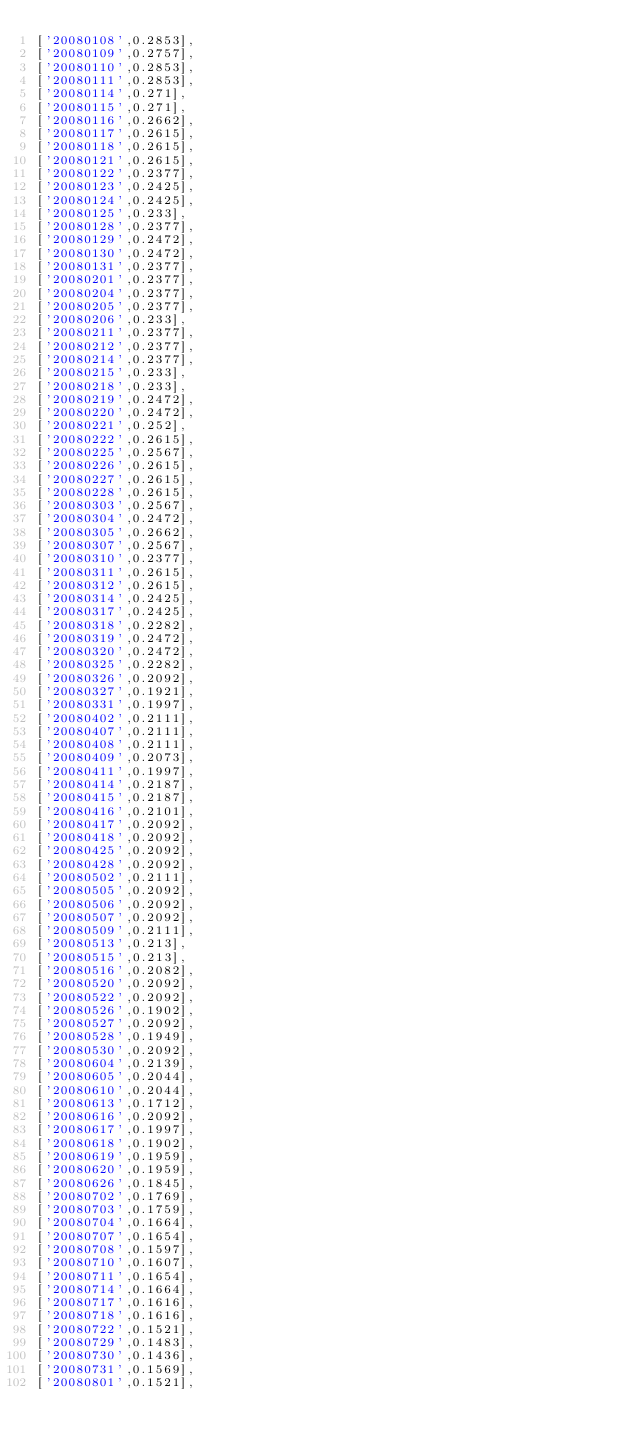Convert code to text. <code><loc_0><loc_0><loc_500><loc_500><_JavaScript_>['20080108',0.2853],
['20080109',0.2757],
['20080110',0.2853],
['20080111',0.2853],
['20080114',0.271],
['20080115',0.271],
['20080116',0.2662],
['20080117',0.2615],
['20080118',0.2615],
['20080121',0.2615],
['20080122',0.2377],
['20080123',0.2425],
['20080124',0.2425],
['20080125',0.233],
['20080128',0.2377],
['20080129',0.2472],
['20080130',0.2472],
['20080131',0.2377],
['20080201',0.2377],
['20080204',0.2377],
['20080205',0.2377],
['20080206',0.233],
['20080211',0.2377],
['20080212',0.2377],
['20080214',0.2377],
['20080215',0.233],
['20080218',0.233],
['20080219',0.2472],
['20080220',0.2472],
['20080221',0.252],
['20080222',0.2615],
['20080225',0.2567],
['20080226',0.2615],
['20080227',0.2615],
['20080228',0.2615],
['20080303',0.2567],
['20080304',0.2472],
['20080305',0.2662],
['20080307',0.2567],
['20080310',0.2377],
['20080311',0.2615],
['20080312',0.2615],
['20080314',0.2425],
['20080317',0.2425],
['20080318',0.2282],
['20080319',0.2472],
['20080320',0.2472],
['20080325',0.2282],
['20080326',0.2092],
['20080327',0.1921],
['20080331',0.1997],
['20080402',0.2111],
['20080407',0.2111],
['20080408',0.2111],
['20080409',0.2073],
['20080411',0.1997],
['20080414',0.2187],
['20080415',0.2187],
['20080416',0.2101],
['20080417',0.2092],
['20080418',0.2092],
['20080425',0.2092],
['20080428',0.2092],
['20080502',0.2111],
['20080505',0.2092],
['20080506',0.2092],
['20080507',0.2092],
['20080509',0.2111],
['20080513',0.213],
['20080515',0.213],
['20080516',0.2082],
['20080520',0.2092],
['20080522',0.2092],
['20080526',0.1902],
['20080527',0.2092],
['20080528',0.1949],
['20080530',0.2092],
['20080604',0.2139],
['20080605',0.2044],
['20080610',0.2044],
['20080613',0.1712],
['20080616',0.2092],
['20080617',0.1997],
['20080618',0.1902],
['20080619',0.1959],
['20080620',0.1959],
['20080626',0.1845],
['20080702',0.1769],
['20080703',0.1759],
['20080704',0.1664],
['20080707',0.1654],
['20080708',0.1597],
['20080710',0.1607],
['20080711',0.1654],
['20080714',0.1664],
['20080717',0.1616],
['20080718',0.1616],
['20080722',0.1521],
['20080729',0.1483],
['20080730',0.1436],
['20080731',0.1569],
['20080801',0.1521],</code> 